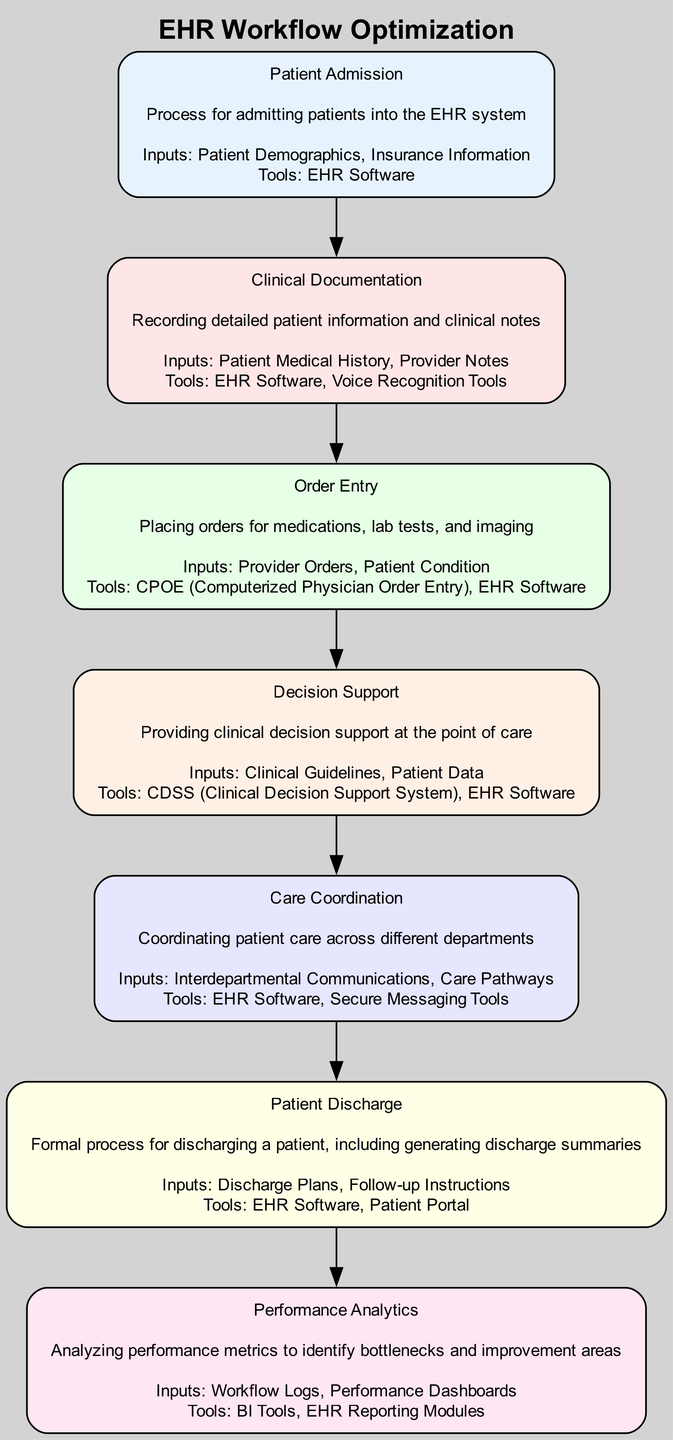What is the first step in the EHR workflow? The first node in the workflow sequence is "Patient Admission," indicating that this is the initial step in the EHR process when a patient is admitted into the system.
Answer: Patient Admission How many tools are used in the "Clinical Documentation" step? The node for "Clinical Documentation" lists two tools: "EHR Software" and "Voice Recognition Tools." Therefore, the total number of tools used in this step is two.
Answer: 2 Which step comes after "Order Entry"? The diagram shows a directed edge from "Order Entry" to "Decision Support," indicating that "Decision Support" follows "Order Entry" in the workflow.
Answer: Decision Support What inputs are required for "Care Coordination"? The node for "Care Coordination" lists two inputs: "Interdepartmental Communications" and "Care Pathways." These are the required inputs for this process.
Answer: Interdepartmental Communications, Care Pathways How many nodes are present in this workflow diagram? There are a total of six nodes in the diagram, representing different steps in the EHR workflow. Counting each unique node from "Patient Admission" to "Performance Analytics," we confirm this total.
Answer: 6 What tools are used during "Patient Discharge"? The "Patient Discharge" step lists two tools: "EHR Software" and "Patient Portal." These are the tools employed in this process to facilitate patient discharge.
Answer: EHR Software, Patient Portal Which process directly follows "Clinical Documentation"? According to the arrow direction in the diagram, after "Clinical Documentation," the workflow proceeds directly to "Order Entry." This indicates that "Order Entry" immediately follows "Clinical Documentation."
Answer: Order Entry What provides clinical decision support in this workflow? The "Decision Support" step explicitly states that it provides clinical decision support at the point of care, making it clear that this is the function of that particular step.
Answer: Decision Support 